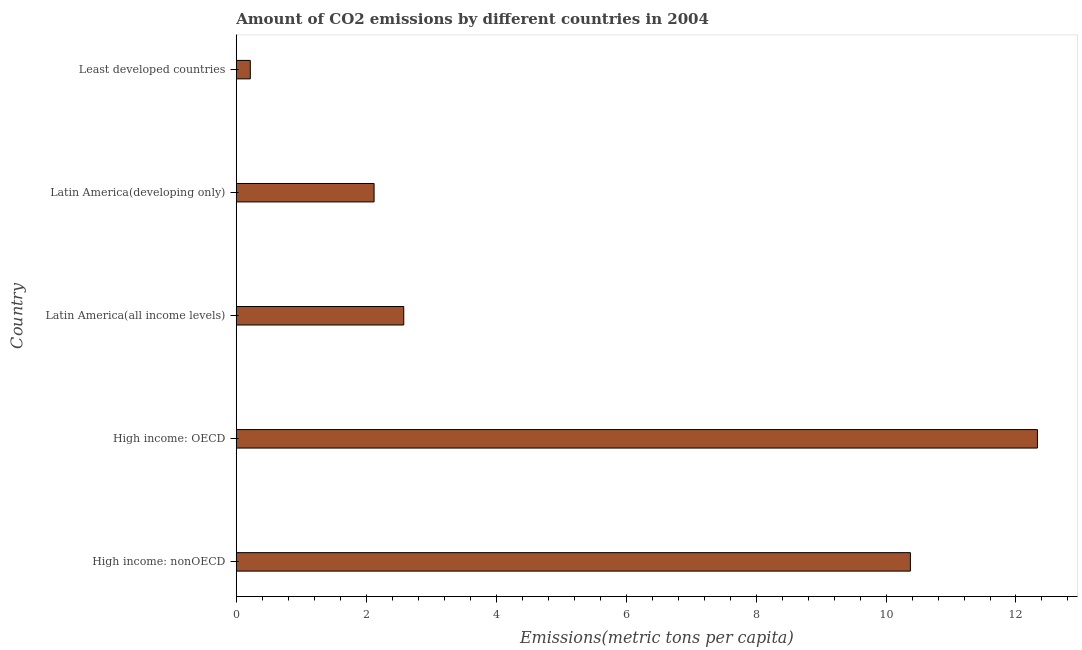Does the graph contain any zero values?
Your response must be concise. No. Does the graph contain grids?
Give a very brief answer. No. What is the title of the graph?
Provide a succinct answer. Amount of CO2 emissions by different countries in 2004. What is the label or title of the X-axis?
Give a very brief answer. Emissions(metric tons per capita). What is the amount of co2 emissions in Latin America(all income levels)?
Ensure brevity in your answer.  2.58. Across all countries, what is the maximum amount of co2 emissions?
Your response must be concise. 12.33. Across all countries, what is the minimum amount of co2 emissions?
Your response must be concise. 0.22. In which country was the amount of co2 emissions maximum?
Offer a terse response. High income: OECD. In which country was the amount of co2 emissions minimum?
Provide a succinct answer. Least developed countries. What is the sum of the amount of co2 emissions?
Keep it short and to the point. 27.62. What is the difference between the amount of co2 emissions in High income: nonOECD and Latin America(developing only)?
Offer a terse response. 8.25. What is the average amount of co2 emissions per country?
Provide a short and direct response. 5.52. What is the median amount of co2 emissions?
Your answer should be very brief. 2.58. In how many countries, is the amount of co2 emissions greater than 12.4 metric tons per capita?
Your answer should be very brief. 0. What is the ratio of the amount of co2 emissions in Latin America(all income levels) to that in Least developed countries?
Your answer should be very brief. 11.93. Is the amount of co2 emissions in High income: nonOECD less than that in Latin America(all income levels)?
Give a very brief answer. No. Is the difference between the amount of co2 emissions in High income: nonOECD and Least developed countries greater than the difference between any two countries?
Offer a terse response. No. What is the difference between the highest and the second highest amount of co2 emissions?
Offer a terse response. 1.96. What is the difference between the highest and the lowest amount of co2 emissions?
Offer a terse response. 12.11. In how many countries, is the amount of co2 emissions greater than the average amount of co2 emissions taken over all countries?
Offer a very short reply. 2. Are all the bars in the graph horizontal?
Provide a short and direct response. Yes. What is the difference between two consecutive major ticks on the X-axis?
Make the answer very short. 2. Are the values on the major ticks of X-axis written in scientific E-notation?
Your response must be concise. No. What is the Emissions(metric tons per capita) in High income: nonOECD?
Your answer should be very brief. 10.37. What is the Emissions(metric tons per capita) in High income: OECD?
Provide a short and direct response. 12.33. What is the Emissions(metric tons per capita) in Latin America(all income levels)?
Make the answer very short. 2.58. What is the Emissions(metric tons per capita) of Latin America(developing only)?
Offer a very short reply. 2.12. What is the Emissions(metric tons per capita) of Least developed countries?
Provide a succinct answer. 0.22. What is the difference between the Emissions(metric tons per capita) in High income: nonOECD and High income: OECD?
Keep it short and to the point. -1.96. What is the difference between the Emissions(metric tons per capita) in High income: nonOECD and Latin America(all income levels)?
Keep it short and to the point. 7.8. What is the difference between the Emissions(metric tons per capita) in High income: nonOECD and Latin America(developing only)?
Your answer should be compact. 8.25. What is the difference between the Emissions(metric tons per capita) in High income: nonOECD and Least developed countries?
Ensure brevity in your answer.  10.16. What is the difference between the Emissions(metric tons per capita) in High income: OECD and Latin America(all income levels)?
Offer a very short reply. 9.75. What is the difference between the Emissions(metric tons per capita) in High income: OECD and Latin America(developing only)?
Offer a very short reply. 10.21. What is the difference between the Emissions(metric tons per capita) in High income: OECD and Least developed countries?
Your response must be concise. 12.11. What is the difference between the Emissions(metric tons per capita) in Latin America(all income levels) and Latin America(developing only)?
Provide a short and direct response. 0.46. What is the difference between the Emissions(metric tons per capita) in Latin America(all income levels) and Least developed countries?
Keep it short and to the point. 2.36. What is the difference between the Emissions(metric tons per capita) in Latin America(developing only) and Least developed countries?
Ensure brevity in your answer.  1.91. What is the ratio of the Emissions(metric tons per capita) in High income: nonOECD to that in High income: OECD?
Your response must be concise. 0.84. What is the ratio of the Emissions(metric tons per capita) in High income: nonOECD to that in Latin America(all income levels)?
Offer a very short reply. 4.03. What is the ratio of the Emissions(metric tons per capita) in High income: nonOECD to that in Latin America(developing only)?
Your response must be concise. 4.89. What is the ratio of the Emissions(metric tons per capita) in High income: nonOECD to that in Least developed countries?
Give a very brief answer. 48.02. What is the ratio of the Emissions(metric tons per capita) in High income: OECD to that in Latin America(all income levels)?
Ensure brevity in your answer.  4.78. What is the ratio of the Emissions(metric tons per capita) in High income: OECD to that in Latin America(developing only)?
Provide a short and direct response. 5.81. What is the ratio of the Emissions(metric tons per capita) in High income: OECD to that in Least developed countries?
Provide a succinct answer. 57.06. What is the ratio of the Emissions(metric tons per capita) in Latin America(all income levels) to that in Latin America(developing only)?
Make the answer very short. 1.22. What is the ratio of the Emissions(metric tons per capita) in Latin America(all income levels) to that in Least developed countries?
Offer a terse response. 11.93. What is the ratio of the Emissions(metric tons per capita) in Latin America(developing only) to that in Least developed countries?
Ensure brevity in your answer.  9.82. 